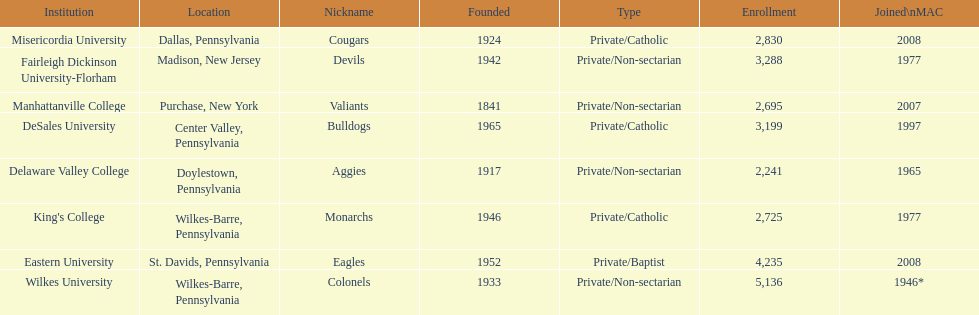What is the enrollment number of misericordia university? 2,830. 